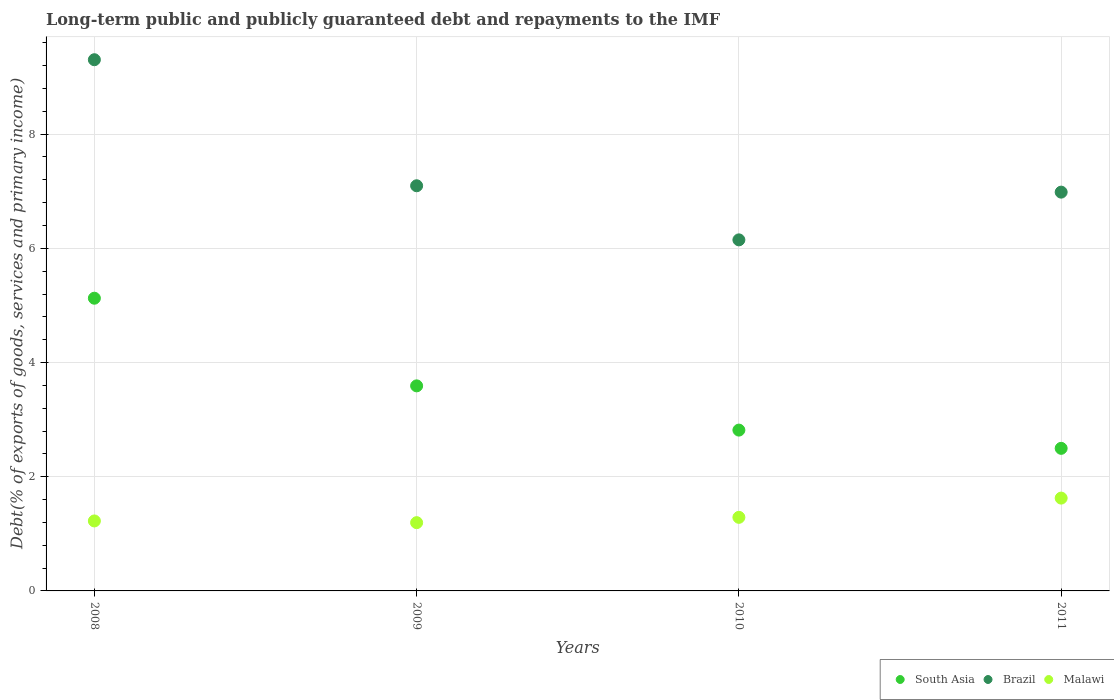How many different coloured dotlines are there?
Provide a succinct answer. 3. What is the debt and repayments in Malawi in 2009?
Your answer should be very brief. 1.2. Across all years, what is the maximum debt and repayments in Malawi?
Offer a terse response. 1.63. Across all years, what is the minimum debt and repayments in South Asia?
Make the answer very short. 2.5. In which year was the debt and repayments in Malawi minimum?
Ensure brevity in your answer.  2009. What is the total debt and repayments in Malawi in the graph?
Offer a very short reply. 5.34. What is the difference between the debt and repayments in Malawi in 2008 and that in 2010?
Keep it short and to the point. -0.06. What is the difference between the debt and repayments in South Asia in 2009 and the debt and repayments in Brazil in 2008?
Your answer should be compact. -5.71. What is the average debt and repayments in Malawi per year?
Provide a short and direct response. 1.33. In the year 2011, what is the difference between the debt and repayments in South Asia and debt and repayments in Malawi?
Offer a very short reply. 0.87. In how many years, is the debt and repayments in Malawi greater than 8.4 %?
Your answer should be compact. 0. What is the ratio of the debt and repayments in Brazil in 2009 to that in 2010?
Offer a terse response. 1.15. Is the debt and repayments in Brazil in 2008 less than that in 2010?
Provide a short and direct response. No. What is the difference between the highest and the second highest debt and repayments in Malawi?
Ensure brevity in your answer.  0.34. What is the difference between the highest and the lowest debt and repayments in Brazil?
Provide a succinct answer. 3.15. In how many years, is the debt and repayments in Brazil greater than the average debt and repayments in Brazil taken over all years?
Provide a succinct answer. 1. Is the sum of the debt and repayments in Malawi in 2008 and 2010 greater than the maximum debt and repayments in South Asia across all years?
Ensure brevity in your answer.  No. Does the debt and repayments in South Asia monotonically increase over the years?
Your answer should be very brief. No. Is the debt and repayments in Malawi strictly less than the debt and repayments in Brazil over the years?
Give a very brief answer. Yes. How many years are there in the graph?
Your response must be concise. 4. Does the graph contain any zero values?
Give a very brief answer. No. Does the graph contain grids?
Offer a very short reply. Yes. Where does the legend appear in the graph?
Keep it short and to the point. Bottom right. What is the title of the graph?
Provide a succinct answer. Long-term public and publicly guaranteed debt and repayments to the IMF. What is the label or title of the X-axis?
Your answer should be compact. Years. What is the label or title of the Y-axis?
Ensure brevity in your answer.  Debt(% of exports of goods, services and primary income). What is the Debt(% of exports of goods, services and primary income) of South Asia in 2008?
Give a very brief answer. 5.13. What is the Debt(% of exports of goods, services and primary income) of Brazil in 2008?
Your response must be concise. 9.3. What is the Debt(% of exports of goods, services and primary income) in Malawi in 2008?
Your answer should be compact. 1.23. What is the Debt(% of exports of goods, services and primary income) of South Asia in 2009?
Your response must be concise. 3.59. What is the Debt(% of exports of goods, services and primary income) of Brazil in 2009?
Give a very brief answer. 7.1. What is the Debt(% of exports of goods, services and primary income) of Malawi in 2009?
Give a very brief answer. 1.2. What is the Debt(% of exports of goods, services and primary income) of South Asia in 2010?
Your answer should be very brief. 2.82. What is the Debt(% of exports of goods, services and primary income) of Brazil in 2010?
Make the answer very short. 6.15. What is the Debt(% of exports of goods, services and primary income) in Malawi in 2010?
Ensure brevity in your answer.  1.29. What is the Debt(% of exports of goods, services and primary income) of South Asia in 2011?
Your response must be concise. 2.5. What is the Debt(% of exports of goods, services and primary income) in Brazil in 2011?
Offer a terse response. 6.98. What is the Debt(% of exports of goods, services and primary income) of Malawi in 2011?
Ensure brevity in your answer.  1.63. Across all years, what is the maximum Debt(% of exports of goods, services and primary income) in South Asia?
Your answer should be very brief. 5.13. Across all years, what is the maximum Debt(% of exports of goods, services and primary income) in Brazil?
Your response must be concise. 9.3. Across all years, what is the maximum Debt(% of exports of goods, services and primary income) of Malawi?
Give a very brief answer. 1.63. Across all years, what is the minimum Debt(% of exports of goods, services and primary income) of South Asia?
Offer a very short reply. 2.5. Across all years, what is the minimum Debt(% of exports of goods, services and primary income) in Brazil?
Your response must be concise. 6.15. Across all years, what is the minimum Debt(% of exports of goods, services and primary income) in Malawi?
Your response must be concise. 1.2. What is the total Debt(% of exports of goods, services and primary income) in South Asia in the graph?
Offer a terse response. 14.03. What is the total Debt(% of exports of goods, services and primary income) of Brazil in the graph?
Make the answer very short. 29.53. What is the total Debt(% of exports of goods, services and primary income) of Malawi in the graph?
Provide a short and direct response. 5.34. What is the difference between the Debt(% of exports of goods, services and primary income) of South Asia in 2008 and that in 2009?
Provide a short and direct response. 1.53. What is the difference between the Debt(% of exports of goods, services and primary income) of Brazil in 2008 and that in 2009?
Ensure brevity in your answer.  2.21. What is the difference between the Debt(% of exports of goods, services and primary income) in Malawi in 2008 and that in 2009?
Ensure brevity in your answer.  0.03. What is the difference between the Debt(% of exports of goods, services and primary income) of South Asia in 2008 and that in 2010?
Give a very brief answer. 2.31. What is the difference between the Debt(% of exports of goods, services and primary income) in Brazil in 2008 and that in 2010?
Your answer should be very brief. 3.15. What is the difference between the Debt(% of exports of goods, services and primary income) of Malawi in 2008 and that in 2010?
Make the answer very short. -0.06. What is the difference between the Debt(% of exports of goods, services and primary income) in South Asia in 2008 and that in 2011?
Provide a succinct answer. 2.63. What is the difference between the Debt(% of exports of goods, services and primary income) in Brazil in 2008 and that in 2011?
Your answer should be very brief. 2.32. What is the difference between the Debt(% of exports of goods, services and primary income) in Malawi in 2008 and that in 2011?
Your response must be concise. -0.4. What is the difference between the Debt(% of exports of goods, services and primary income) of South Asia in 2009 and that in 2010?
Your answer should be very brief. 0.77. What is the difference between the Debt(% of exports of goods, services and primary income) in Brazil in 2009 and that in 2010?
Provide a succinct answer. 0.95. What is the difference between the Debt(% of exports of goods, services and primary income) in Malawi in 2009 and that in 2010?
Make the answer very short. -0.09. What is the difference between the Debt(% of exports of goods, services and primary income) in South Asia in 2009 and that in 2011?
Your answer should be very brief. 1.09. What is the difference between the Debt(% of exports of goods, services and primary income) of Brazil in 2009 and that in 2011?
Your answer should be compact. 0.11. What is the difference between the Debt(% of exports of goods, services and primary income) of Malawi in 2009 and that in 2011?
Your answer should be compact. -0.43. What is the difference between the Debt(% of exports of goods, services and primary income) of South Asia in 2010 and that in 2011?
Offer a very short reply. 0.32. What is the difference between the Debt(% of exports of goods, services and primary income) of Brazil in 2010 and that in 2011?
Offer a very short reply. -0.84. What is the difference between the Debt(% of exports of goods, services and primary income) in Malawi in 2010 and that in 2011?
Provide a succinct answer. -0.34. What is the difference between the Debt(% of exports of goods, services and primary income) in South Asia in 2008 and the Debt(% of exports of goods, services and primary income) in Brazil in 2009?
Your response must be concise. -1.97. What is the difference between the Debt(% of exports of goods, services and primary income) in South Asia in 2008 and the Debt(% of exports of goods, services and primary income) in Malawi in 2009?
Provide a succinct answer. 3.93. What is the difference between the Debt(% of exports of goods, services and primary income) of Brazil in 2008 and the Debt(% of exports of goods, services and primary income) of Malawi in 2009?
Provide a succinct answer. 8.11. What is the difference between the Debt(% of exports of goods, services and primary income) in South Asia in 2008 and the Debt(% of exports of goods, services and primary income) in Brazil in 2010?
Provide a succinct answer. -1.02. What is the difference between the Debt(% of exports of goods, services and primary income) of South Asia in 2008 and the Debt(% of exports of goods, services and primary income) of Malawi in 2010?
Your answer should be very brief. 3.84. What is the difference between the Debt(% of exports of goods, services and primary income) of Brazil in 2008 and the Debt(% of exports of goods, services and primary income) of Malawi in 2010?
Ensure brevity in your answer.  8.01. What is the difference between the Debt(% of exports of goods, services and primary income) in South Asia in 2008 and the Debt(% of exports of goods, services and primary income) in Brazil in 2011?
Give a very brief answer. -1.86. What is the difference between the Debt(% of exports of goods, services and primary income) of South Asia in 2008 and the Debt(% of exports of goods, services and primary income) of Malawi in 2011?
Provide a succinct answer. 3.5. What is the difference between the Debt(% of exports of goods, services and primary income) in Brazil in 2008 and the Debt(% of exports of goods, services and primary income) in Malawi in 2011?
Give a very brief answer. 7.68. What is the difference between the Debt(% of exports of goods, services and primary income) in South Asia in 2009 and the Debt(% of exports of goods, services and primary income) in Brazil in 2010?
Your answer should be very brief. -2.56. What is the difference between the Debt(% of exports of goods, services and primary income) in South Asia in 2009 and the Debt(% of exports of goods, services and primary income) in Malawi in 2010?
Offer a terse response. 2.3. What is the difference between the Debt(% of exports of goods, services and primary income) in Brazil in 2009 and the Debt(% of exports of goods, services and primary income) in Malawi in 2010?
Provide a short and direct response. 5.81. What is the difference between the Debt(% of exports of goods, services and primary income) of South Asia in 2009 and the Debt(% of exports of goods, services and primary income) of Brazil in 2011?
Your answer should be very brief. -3.39. What is the difference between the Debt(% of exports of goods, services and primary income) of South Asia in 2009 and the Debt(% of exports of goods, services and primary income) of Malawi in 2011?
Make the answer very short. 1.97. What is the difference between the Debt(% of exports of goods, services and primary income) of Brazil in 2009 and the Debt(% of exports of goods, services and primary income) of Malawi in 2011?
Your answer should be compact. 5.47. What is the difference between the Debt(% of exports of goods, services and primary income) in South Asia in 2010 and the Debt(% of exports of goods, services and primary income) in Brazil in 2011?
Offer a terse response. -4.17. What is the difference between the Debt(% of exports of goods, services and primary income) of South Asia in 2010 and the Debt(% of exports of goods, services and primary income) of Malawi in 2011?
Give a very brief answer. 1.19. What is the difference between the Debt(% of exports of goods, services and primary income) of Brazil in 2010 and the Debt(% of exports of goods, services and primary income) of Malawi in 2011?
Your answer should be very brief. 4.52. What is the average Debt(% of exports of goods, services and primary income) in South Asia per year?
Your answer should be very brief. 3.51. What is the average Debt(% of exports of goods, services and primary income) in Brazil per year?
Give a very brief answer. 7.38. What is the average Debt(% of exports of goods, services and primary income) of Malawi per year?
Provide a succinct answer. 1.33. In the year 2008, what is the difference between the Debt(% of exports of goods, services and primary income) of South Asia and Debt(% of exports of goods, services and primary income) of Brazil?
Make the answer very short. -4.18. In the year 2008, what is the difference between the Debt(% of exports of goods, services and primary income) in South Asia and Debt(% of exports of goods, services and primary income) in Malawi?
Keep it short and to the point. 3.9. In the year 2008, what is the difference between the Debt(% of exports of goods, services and primary income) of Brazil and Debt(% of exports of goods, services and primary income) of Malawi?
Provide a succinct answer. 8.08. In the year 2009, what is the difference between the Debt(% of exports of goods, services and primary income) in South Asia and Debt(% of exports of goods, services and primary income) in Brazil?
Offer a terse response. -3.5. In the year 2009, what is the difference between the Debt(% of exports of goods, services and primary income) of South Asia and Debt(% of exports of goods, services and primary income) of Malawi?
Offer a terse response. 2.4. In the year 2009, what is the difference between the Debt(% of exports of goods, services and primary income) of Brazil and Debt(% of exports of goods, services and primary income) of Malawi?
Keep it short and to the point. 5.9. In the year 2010, what is the difference between the Debt(% of exports of goods, services and primary income) of South Asia and Debt(% of exports of goods, services and primary income) of Brazil?
Provide a short and direct response. -3.33. In the year 2010, what is the difference between the Debt(% of exports of goods, services and primary income) in South Asia and Debt(% of exports of goods, services and primary income) in Malawi?
Give a very brief answer. 1.53. In the year 2010, what is the difference between the Debt(% of exports of goods, services and primary income) in Brazil and Debt(% of exports of goods, services and primary income) in Malawi?
Your response must be concise. 4.86. In the year 2011, what is the difference between the Debt(% of exports of goods, services and primary income) in South Asia and Debt(% of exports of goods, services and primary income) in Brazil?
Make the answer very short. -4.49. In the year 2011, what is the difference between the Debt(% of exports of goods, services and primary income) in South Asia and Debt(% of exports of goods, services and primary income) in Malawi?
Make the answer very short. 0.87. In the year 2011, what is the difference between the Debt(% of exports of goods, services and primary income) of Brazil and Debt(% of exports of goods, services and primary income) of Malawi?
Give a very brief answer. 5.36. What is the ratio of the Debt(% of exports of goods, services and primary income) in South Asia in 2008 to that in 2009?
Provide a short and direct response. 1.43. What is the ratio of the Debt(% of exports of goods, services and primary income) of Brazil in 2008 to that in 2009?
Offer a very short reply. 1.31. What is the ratio of the Debt(% of exports of goods, services and primary income) in Malawi in 2008 to that in 2009?
Your answer should be compact. 1.03. What is the ratio of the Debt(% of exports of goods, services and primary income) in South Asia in 2008 to that in 2010?
Offer a very short reply. 1.82. What is the ratio of the Debt(% of exports of goods, services and primary income) in Brazil in 2008 to that in 2010?
Your answer should be compact. 1.51. What is the ratio of the Debt(% of exports of goods, services and primary income) in Malawi in 2008 to that in 2010?
Keep it short and to the point. 0.95. What is the ratio of the Debt(% of exports of goods, services and primary income) in South Asia in 2008 to that in 2011?
Keep it short and to the point. 2.05. What is the ratio of the Debt(% of exports of goods, services and primary income) of Brazil in 2008 to that in 2011?
Keep it short and to the point. 1.33. What is the ratio of the Debt(% of exports of goods, services and primary income) of Malawi in 2008 to that in 2011?
Ensure brevity in your answer.  0.75. What is the ratio of the Debt(% of exports of goods, services and primary income) in South Asia in 2009 to that in 2010?
Your response must be concise. 1.28. What is the ratio of the Debt(% of exports of goods, services and primary income) of Brazil in 2009 to that in 2010?
Provide a short and direct response. 1.15. What is the ratio of the Debt(% of exports of goods, services and primary income) of Malawi in 2009 to that in 2010?
Provide a short and direct response. 0.93. What is the ratio of the Debt(% of exports of goods, services and primary income) in South Asia in 2009 to that in 2011?
Provide a succinct answer. 1.44. What is the ratio of the Debt(% of exports of goods, services and primary income) of Brazil in 2009 to that in 2011?
Give a very brief answer. 1.02. What is the ratio of the Debt(% of exports of goods, services and primary income) of Malawi in 2009 to that in 2011?
Keep it short and to the point. 0.74. What is the ratio of the Debt(% of exports of goods, services and primary income) of South Asia in 2010 to that in 2011?
Keep it short and to the point. 1.13. What is the ratio of the Debt(% of exports of goods, services and primary income) in Brazil in 2010 to that in 2011?
Provide a succinct answer. 0.88. What is the ratio of the Debt(% of exports of goods, services and primary income) of Malawi in 2010 to that in 2011?
Provide a short and direct response. 0.79. What is the difference between the highest and the second highest Debt(% of exports of goods, services and primary income) in South Asia?
Make the answer very short. 1.53. What is the difference between the highest and the second highest Debt(% of exports of goods, services and primary income) in Brazil?
Offer a very short reply. 2.21. What is the difference between the highest and the second highest Debt(% of exports of goods, services and primary income) in Malawi?
Provide a short and direct response. 0.34. What is the difference between the highest and the lowest Debt(% of exports of goods, services and primary income) in South Asia?
Offer a very short reply. 2.63. What is the difference between the highest and the lowest Debt(% of exports of goods, services and primary income) in Brazil?
Offer a very short reply. 3.15. What is the difference between the highest and the lowest Debt(% of exports of goods, services and primary income) in Malawi?
Your response must be concise. 0.43. 